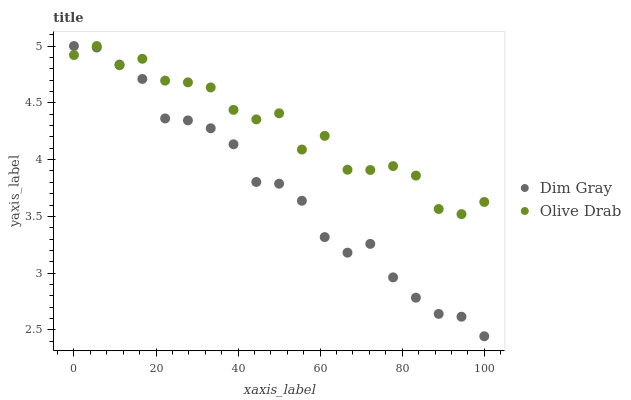Does Dim Gray have the minimum area under the curve?
Answer yes or no. Yes. Does Olive Drab have the maximum area under the curve?
Answer yes or no. Yes. Does Olive Drab have the minimum area under the curve?
Answer yes or no. No. Is Dim Gray the smoothest?
Answer yes or no. Yes. Is Olive Drab the roughest?
Answer yes or no. Yes. Is Olive Drab the smoothest?
Answer yes or no. No. Does Dim Gray have the lowest value?
Answer yes or no. Yes. Does Olive Drab have the lowest value?
Answer yes or no. No. Does Olive Drab have the highest value?
Answer yes or no. Yes. Does Dim Gray intersect Olive Drab?
Answer yes or no. Yes. Is Dim Gray less than Olive Drab?
Answer yes or no. No. Is Dim Gray greater than Olive Drab?
Answer yes or no. No. 